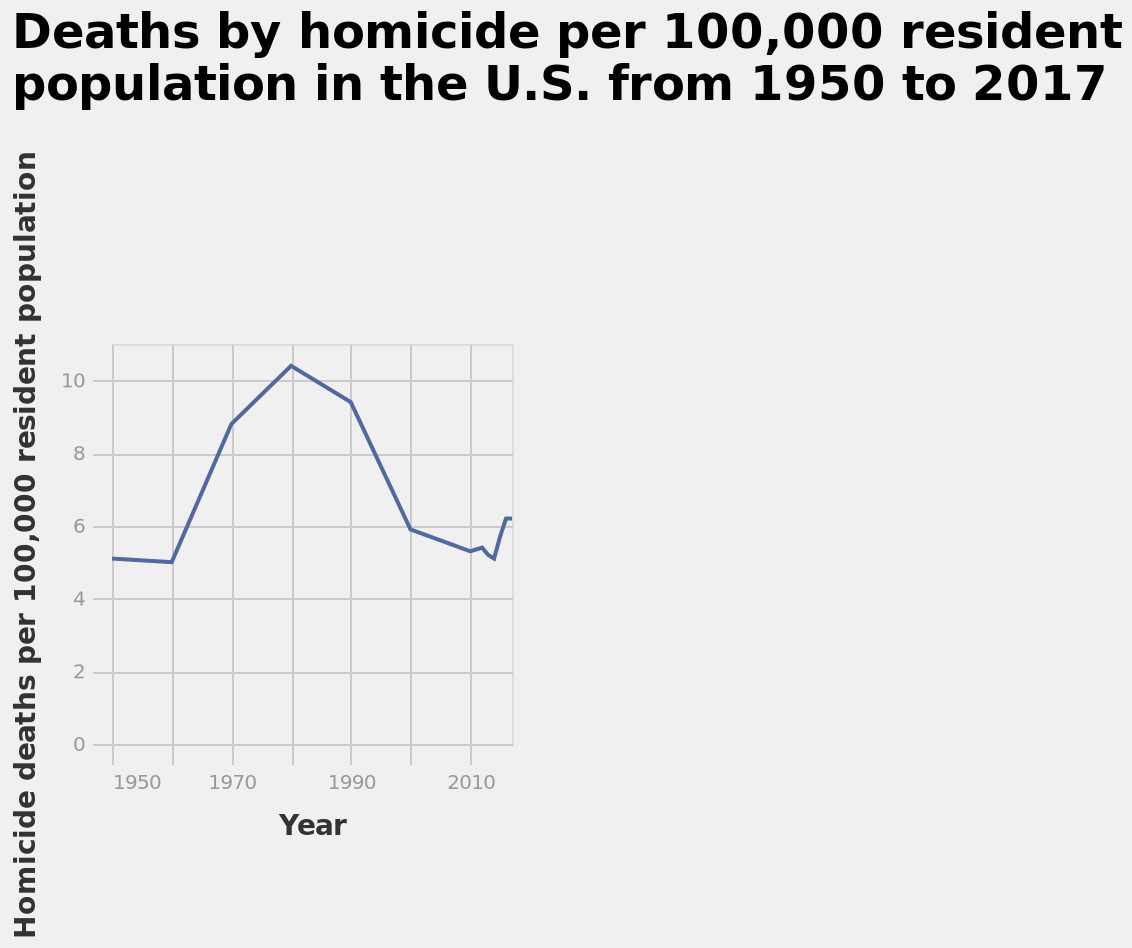<image>
What does the y-axis measure? The y-axis measures homicide deaths per 100,000 resident population. When did the number of deaths start to rise again after the decrease?  The number of deaths started to rise again around 2010. 